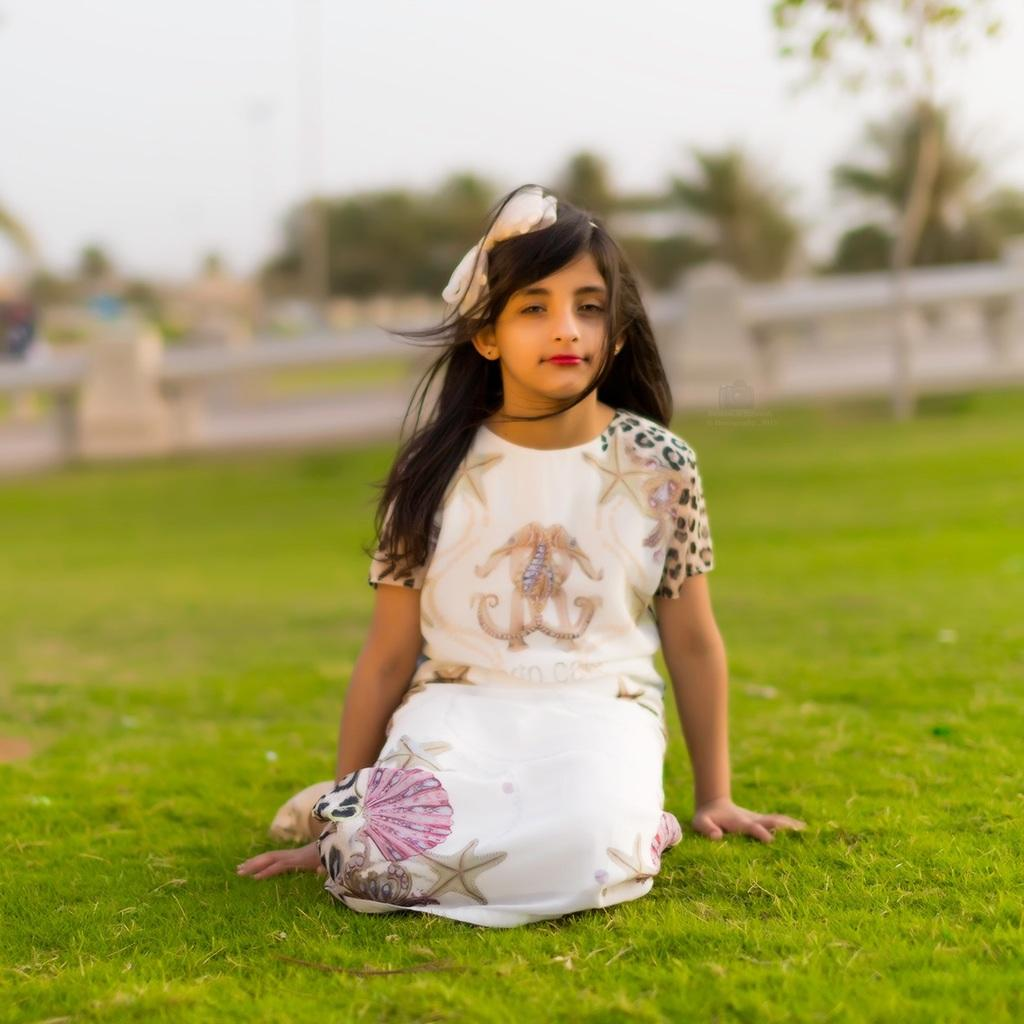Who is the main subject in the image? There is a girl in the image. What is the girl doing in the image? The girl is sitting on the grass. Can you describe the background of the image? The background of the image is blurry, and it might include the sky, trees, and a fence. What type of paste is the girl using to stick the deer to the field in the image? There is no paste, deer, or field present in the image. 